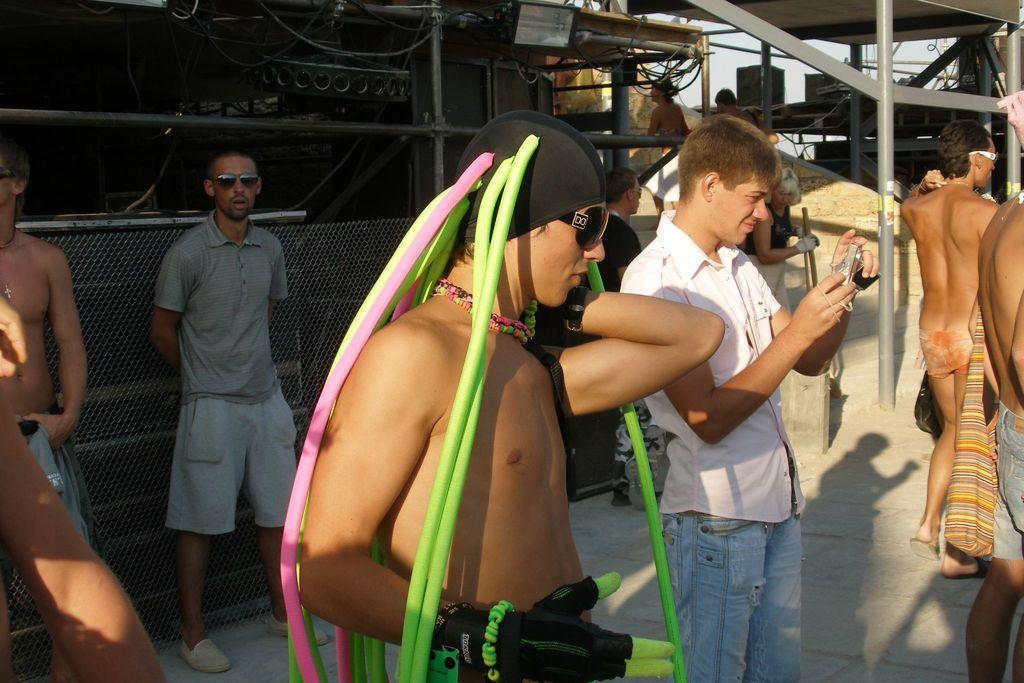What are the people in the image doing? The people in the image are standing on the ground. What can be seen in the background of the image? In the background of the image, there is a light, a fence, rods, boxes, and the sky. Can you describe the fence in the background? The fence in the background is a linear structure made of vertical and horizontal elements. What is the color of the sky in the image? The sky is visible in the background of the image, but the color is not specified in the provided facts. What type of brush is being used to paint the texture on the boxes in the image? There is no brush or painting activity present in the image; the boxes are simply visible in the background. 